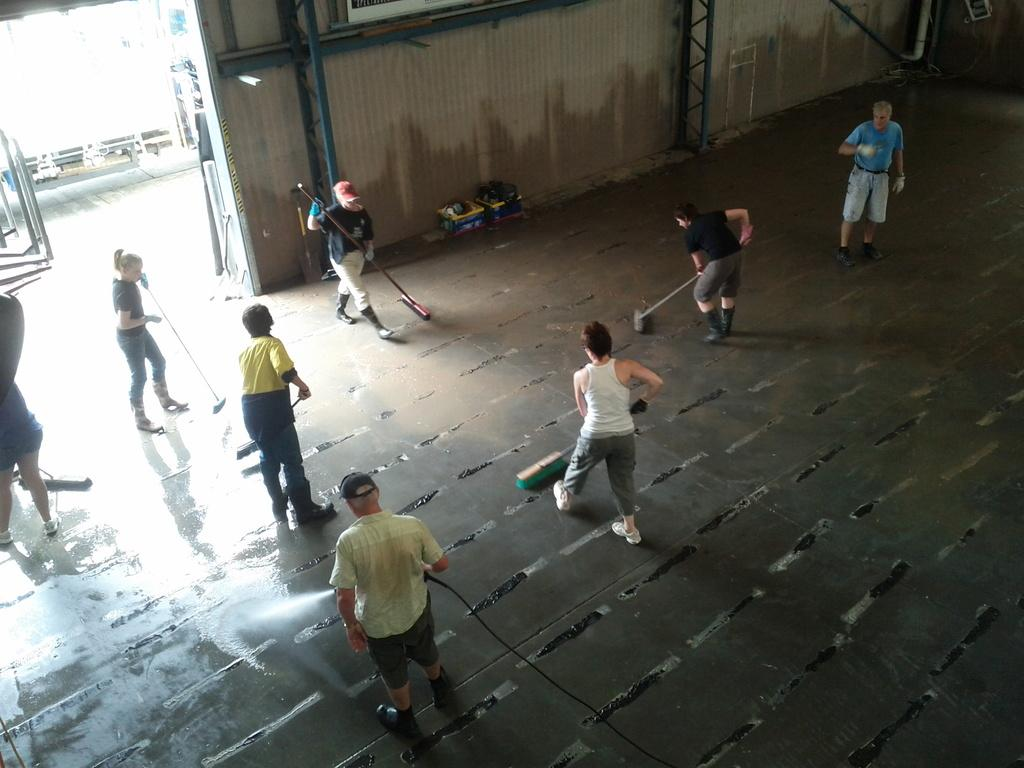Who is present in the image? There are people in the image. What are the people doing in the image? The people are cleaning the floor. What can be seen in the background of the image? There is a wall visible in the image. Where is the throne located in the image? There is no throne present in the image. What type of sheet is covering the people in the image? There are no sheets covering the people in the image; they are cleaning the floor. 